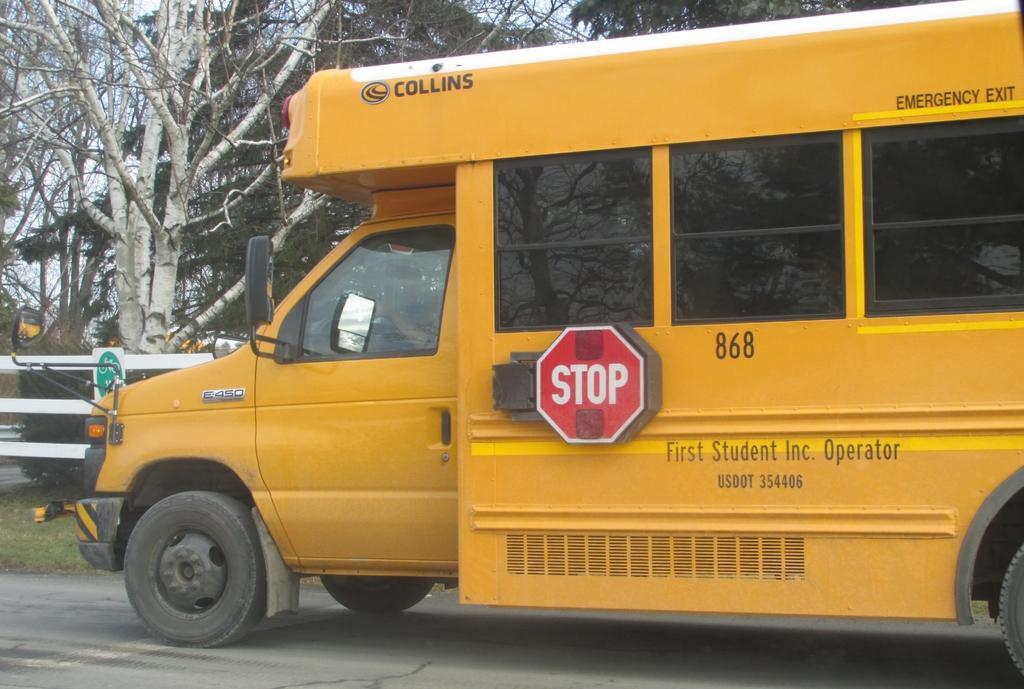Please provide a concise description of this image. In this image we can see a vehicle which is in yellow color on the road and there is some text on it and we can see some trees and a sign board in the background and we can see the sky. 